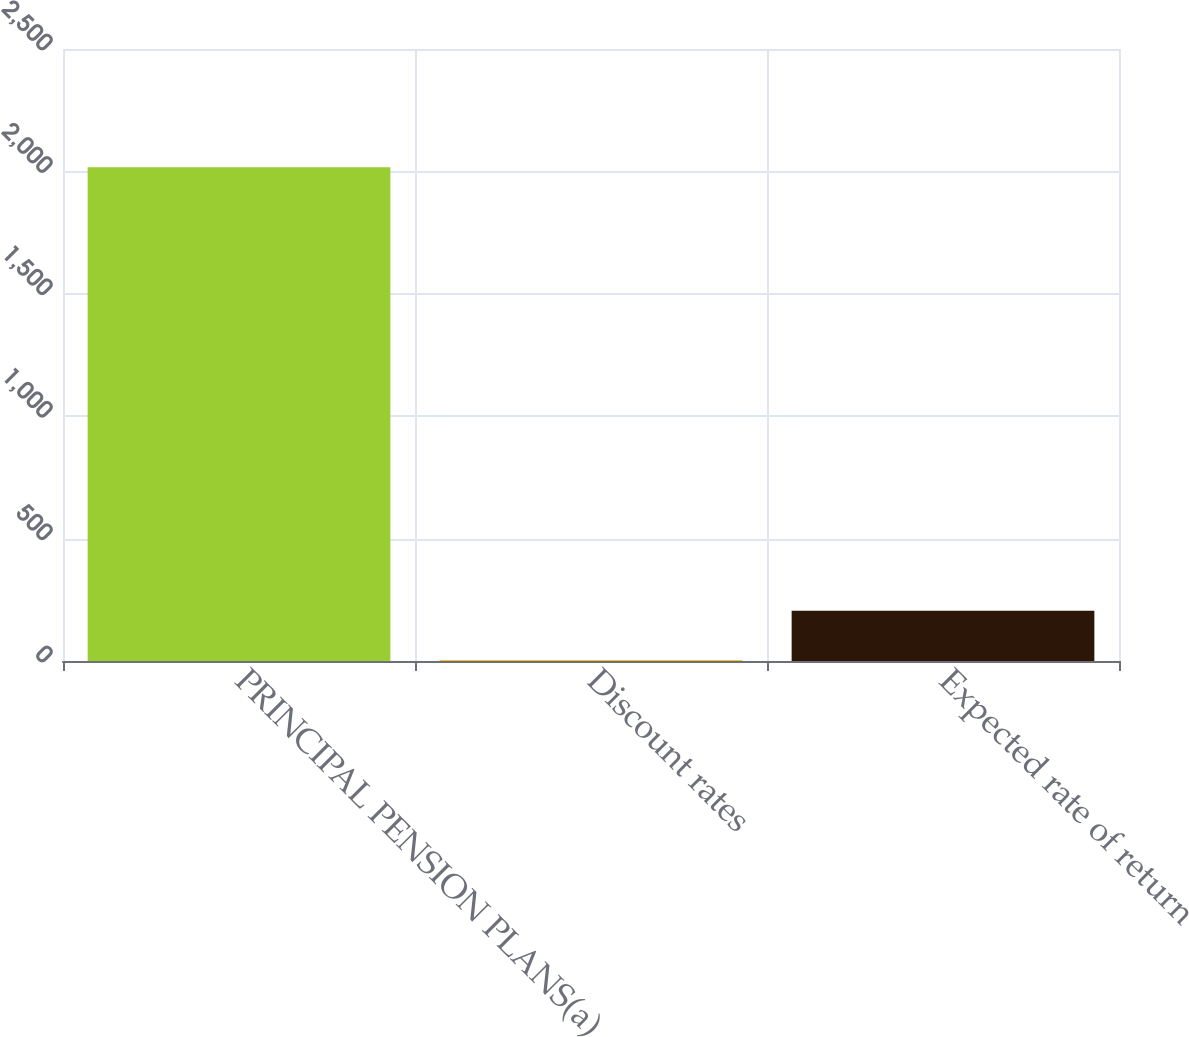Convert chart. <chart><loc_0><loc_0><loc_500><loc_500><bar_chart><fcel>PRINCIPAL PENSION PLANS(a)<fcel>Discount rates<fcel>Expected rate of return<nl><fcel>2017<fcel>4.11<fcel>205.4<nl></chart> 